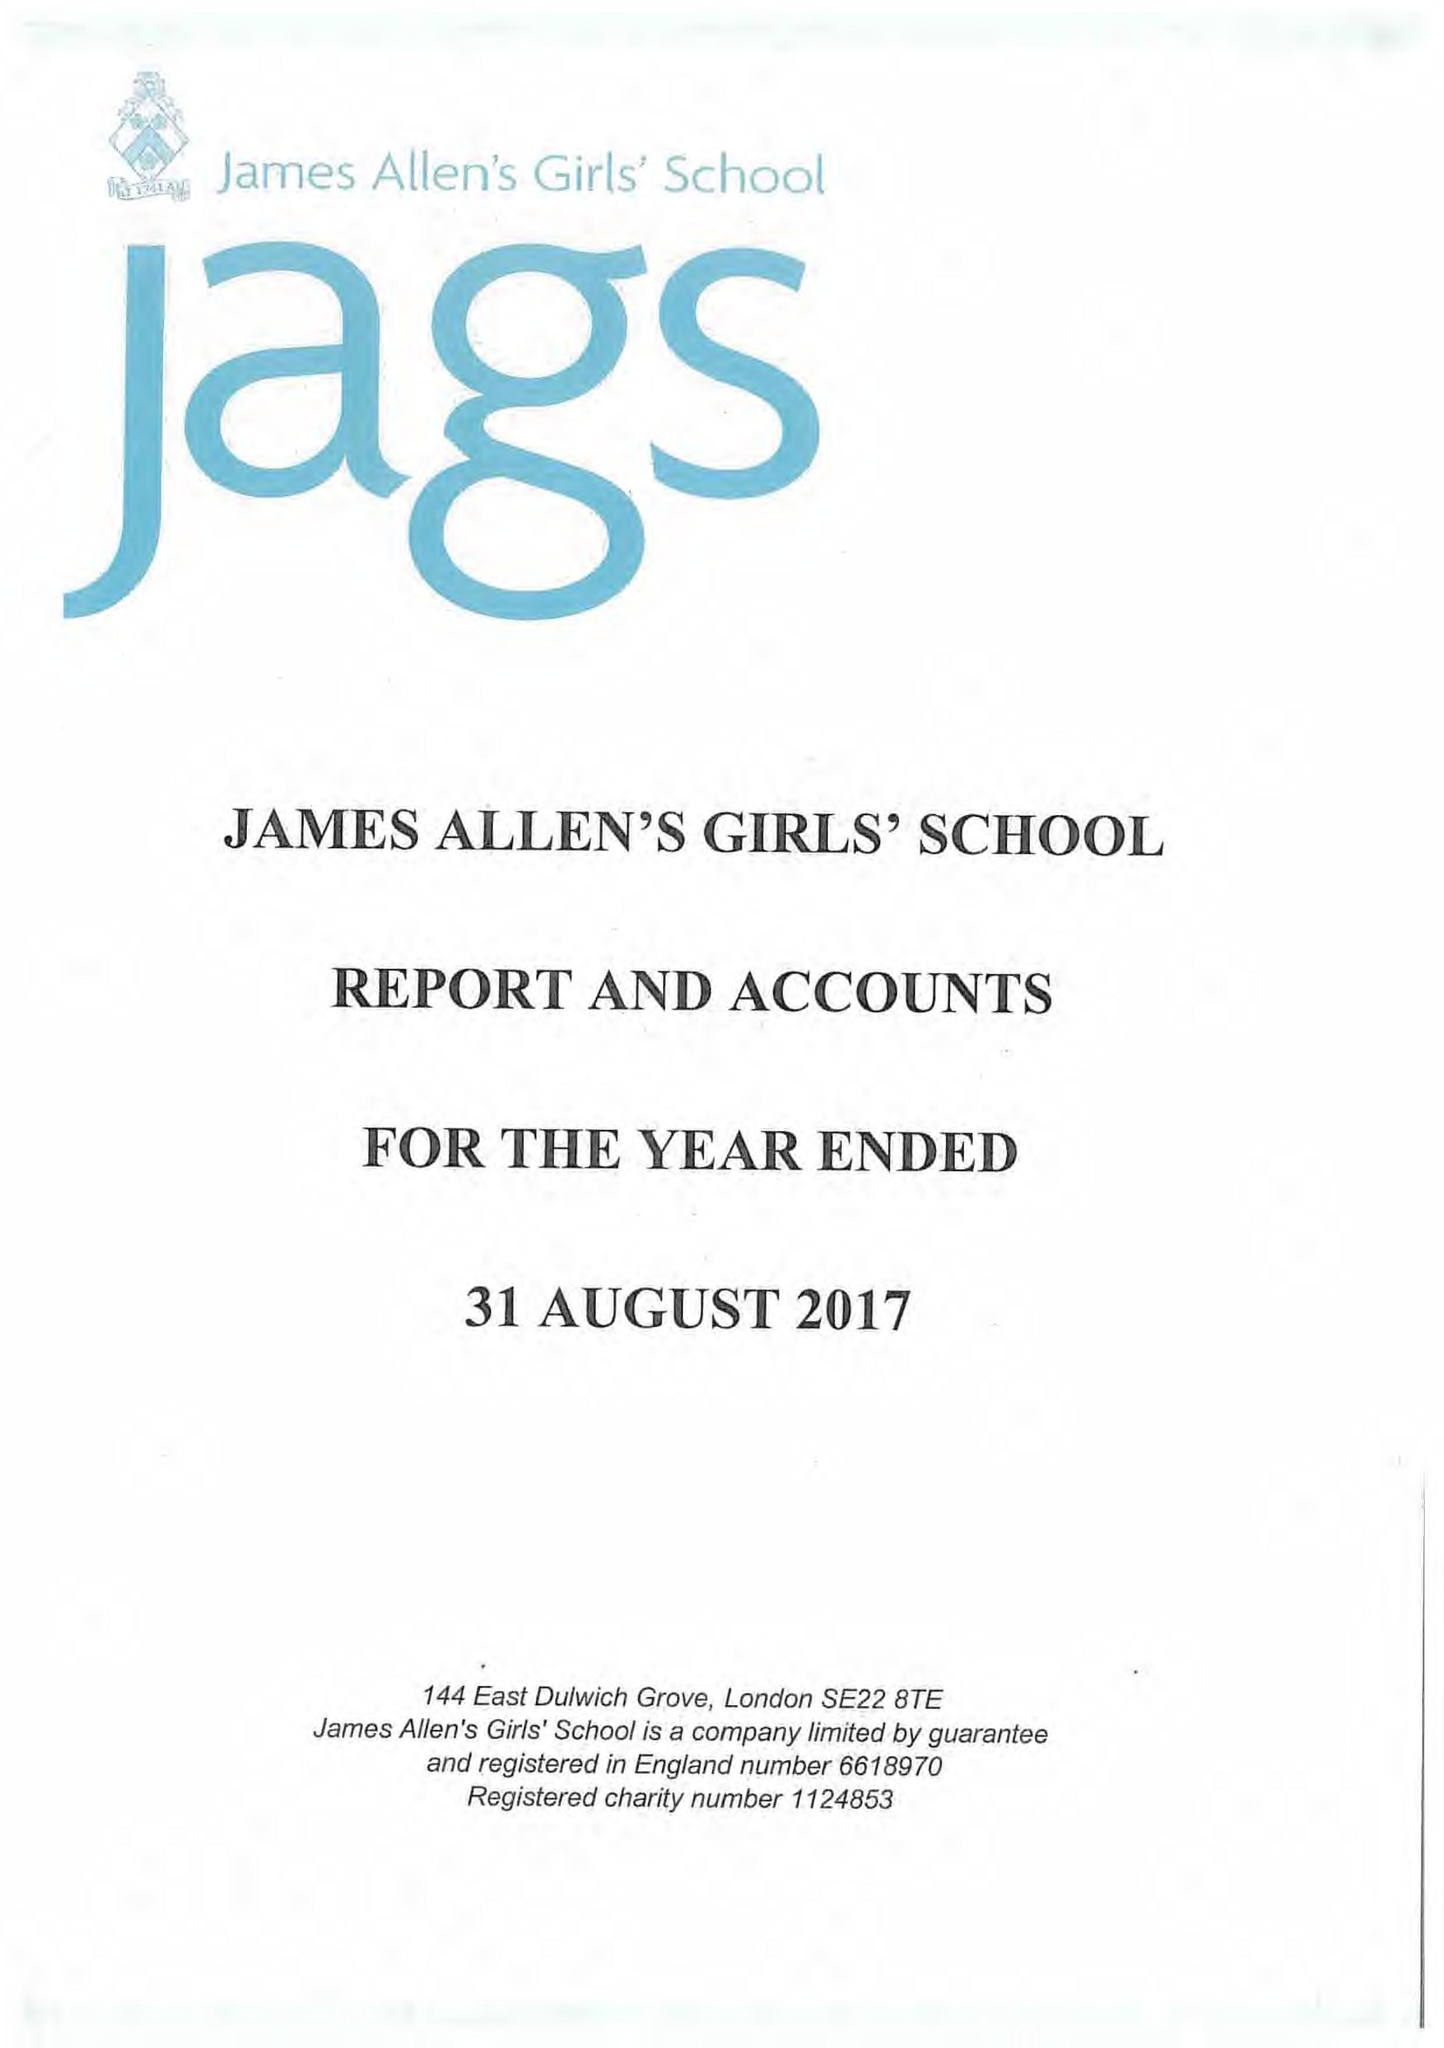What is the value for the address__post_town?
Answer the question using a single word or phrase. LONDON 